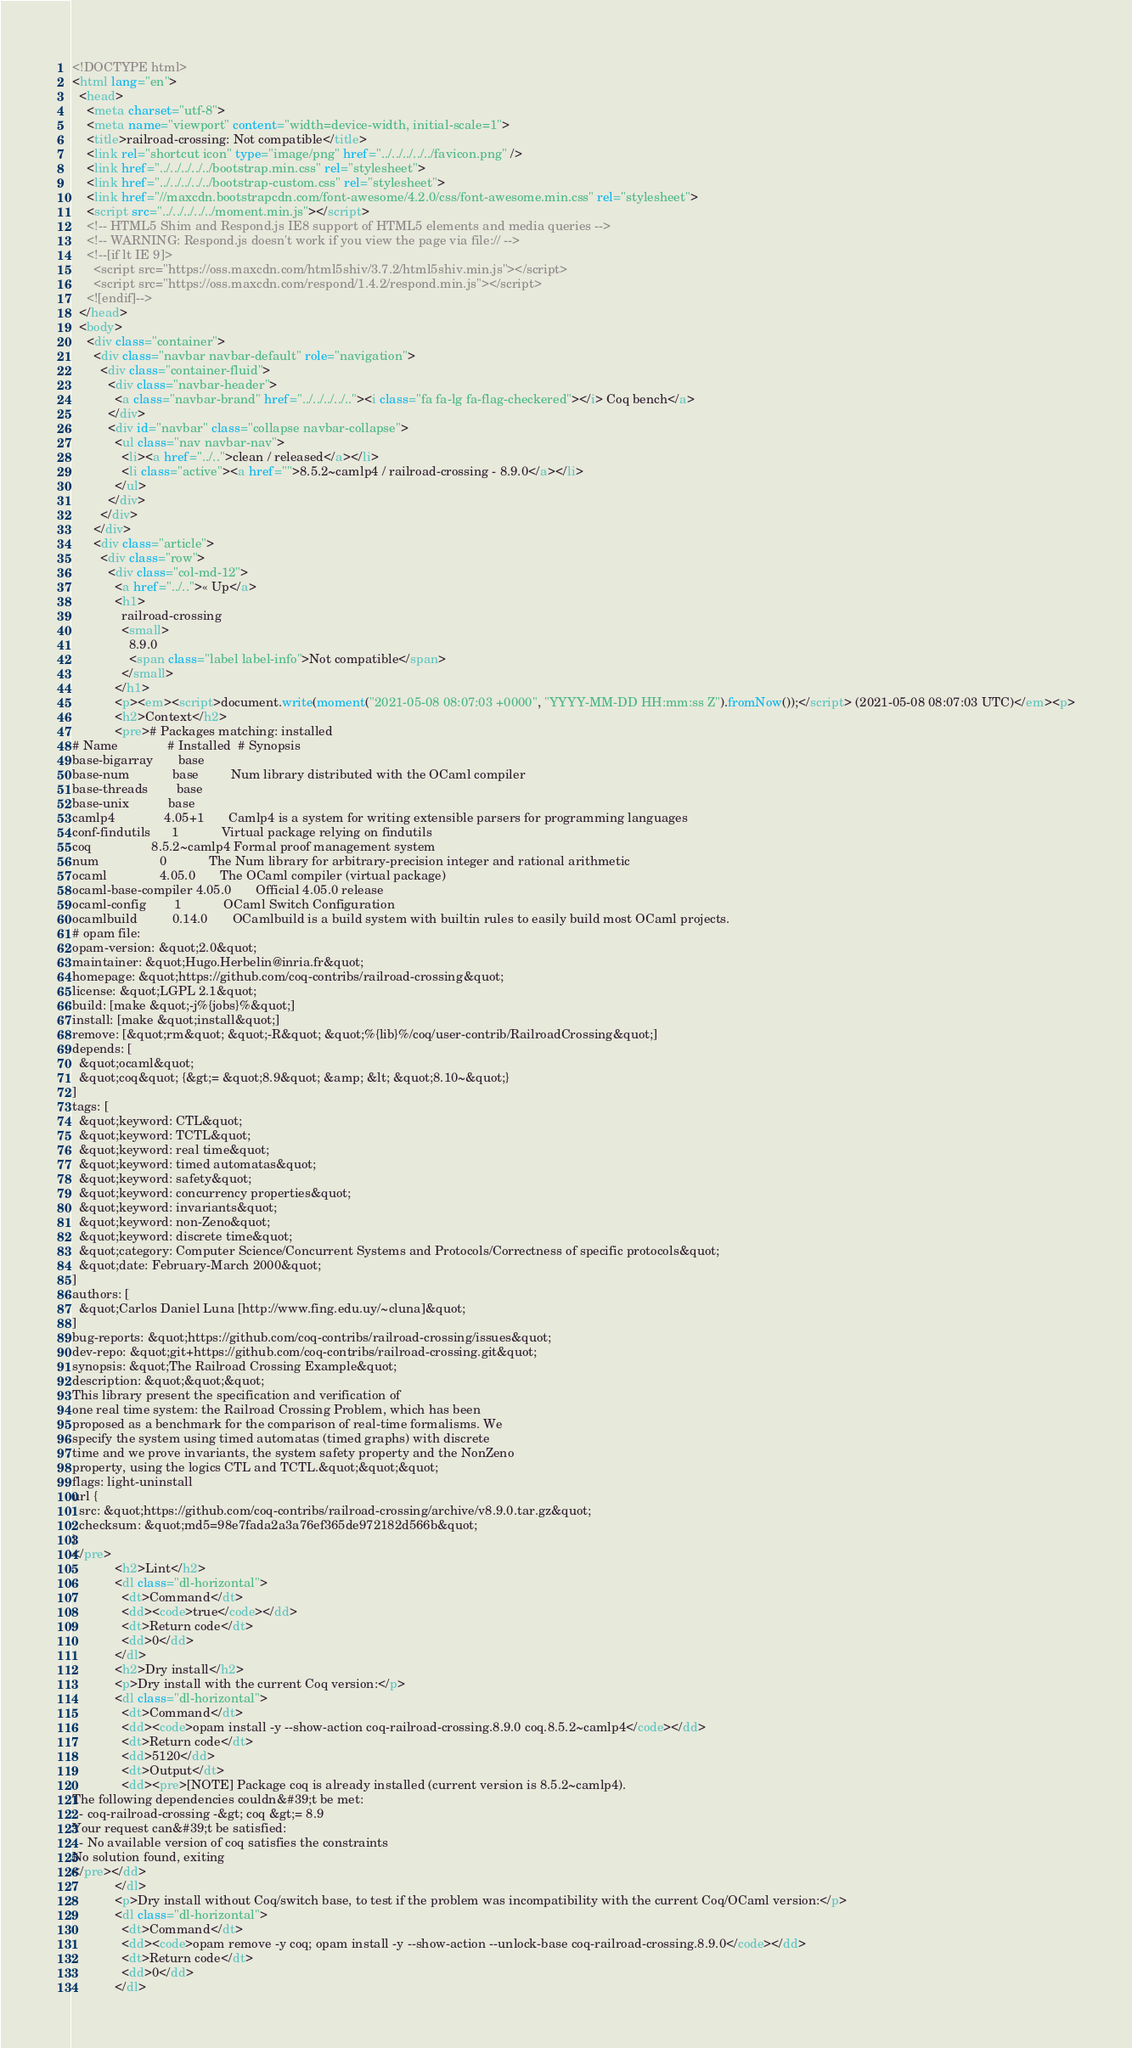<code> <loc_0><loc_0><loc_500><loc_500><_HTML_><!DOCTYPE html>
<html lang="en">
  <head>
    <meta charset="utf-8">
    <meta name="viewport" content="width=device-width, initial-scale=1">
    <title>railroad-crossing: Not compatible</title>
    <link rel="shortcut icon" type="image/png" href="../../../../../favicon.png" />
    <link href="../../../../../bootstrap.min.css" rel="stylesheet">
    <link href="../../../../../bootstrap-custom.css" rel="stylesheet">
    <link href="//maxcdn.bootstrapcdn.com/font-awesome/4.2.0/css/font-awesome.min.css" rel="stylesheet">
    <script src="../../../../../moment.min.js"></script>
    <!-- HTML5 Shim and Respond.js IE8 support of HTML5 elements and media queries -->
    <!-- WARNING: Respond.js doesn't work if you view the page via file:// -->
    <!--[if lt IE 9]>
      <script src="https://oss.maxcdn.com/html5shiv/3.7.2/html5shiv.min.js"></script>
      <script src="https://oss.maxcdn.com/respond/1.4.2/respond.min.js"></script>
    <![endif]-->
  </head>
  <body>
    <div class="container">
      <div class="navbar navbar-default" role="navigation">
        <div class="container-fluid">
          <div class="navbar-header">
            <a class="navbar-brand" href="../../../../.."><i class="fa fa-lg fa-flag-checkered"></i> Coq bench</a>
          </div>
          <div id="navbar" class="collapse navbar-collapse">
            <ul class="nav navbar-nav">
              <li><a href="../..">clean / released</a></li>
              <li class="active"><a href="">8.5.2~camlp4 / railroad-crossing - 8.9.0</a></li>
            </ul>
          </div>
        </div>
      </div>
      <div class="article">
        <div class="row">
          <div class="col-md-12">
            <a href="../..">« Up</a>
            <h1>
              railroad-crossing
              <small>
                8.9.0
                <span class="label label-info">Not compatible</span>
              </small>
            </h1>
            <p><em><script>document.write(moment("2021-05-08 08:07:03 +0000", "YYYY-MM-DD HH:mm:ss Z").fromNow());</script> (2021-05-08 08:07:03 UTC)</em><p>
            <h2>Context</h2>
            <pre># Packages matching: installed
# Name              # Installed  # Synopsis
base-bigarray       base
base-num            base         Num library distributed with the OCaml compiler
base-threads        base
base-unix           base
camlp4              4.05+1       Camlp4 is a system for writing extensible parsers for programming languages
conf-findutils      1            Virtual package relying on findutils
coq                 8.5.2~camlp4 Formal proof management system
num                 0            The Num library for arbitrary-precision integer and rational arithmetic
ocaml               4.05.0       The OCaml compiler (virtual package)
ocaml-base-compiler 4.05.0       Official 4.05.0 release
ocaml-config        1            OCaml Switch Configuration
ocamlbuild          0.14.0       OCamlbuild is a build system with builtin rules to easily build most OCaml projects.
# opam file:
opam-version: &quot;2.0&quot;
maintainer: &quot;Hugo.Herbelin@inria.fr&quot;
homepage: &quot;https://github.com/coq-contribs/railroad-crossing&quot;
license: &quot;LGPL 2.1&quot;
build: [make &quot;-j%{jobs}%&quot;]
install: [make &quot;install&quot;]
remove: [&quot;rm&quot; &quot;-R&quot; &quot;%{lib}%/coq/user-contrib/RailroadCrossing&quot;]
depends: [
  &quot;ocaml&quot;
  &quot;coq&quot; {&gt;= &quot;8.9&quot; &amp; &lt; &quot;8.10~&quot;}
]
tags: [
  &quot;keyword: CTL&quot;
  &quot;keyword: TCTL&quot;
  &quot;keyword: real time&quot;
  &quot;keyword: timed automatas&quot;
  &quot;keyword: safety&quot;
  &quot;keyword: concurrency properties&quot;
  &quot;keyword: invariants&quot;
  &quot;keyword: non-Zeno&quot;
  &quot;keyword: discrete time&quot;
  &quot;category: Computer Science/Concurrent Systems and Protocols/Correctness of specific protocols&quot;
  &quot;date: February-March 2000&quot;
]
authors: [
  &quot;Carlos Daniel Luna [http://www.fing.edu.uy/~cluna]&quot;
]
bug-reports: &quot;https://github.com/coq-contribs/railroad-crossing/issues&quot;
dev-repo: &quot;git+https://github.com/coq-contribs/railroad-crossing.git&quot;
synopsis: &quot;The Railroad Crossing Example&quot;
description: &quot;&quot;&quot;
This library present the specification and verification of
one real time system: the Railroad Crossing Problem, which has been
proposed as a benchmark for the comparison of real-time formalisms. We
specify the system using timed automatas (timed graphs) with discrete
time and we prove invariants, the system safety property and the NonZeno
property, using the logics CTL and TCTL.&quot;&quot;&quot;
flags: light-uninstall
url {
  src: &quot;https://github.com/coq-contribs/railroad-crossing/archive/v8.9.0.tar.gz&quot;
  checksum: &quot;md5=98e7fada2a3a76ef365de972182d566b&quot;
}
</pre>
            <h2>Lint</h2>
            <dl class="dl-horizontal">
              <dt>Command</dt>
              <dd><code>true</code></dd>
              <dt>Return code</dt>
              <dd>0</dd>
            </dl>
            <h2>Dry install</h2>
            <p>Dry install with the current Coq version:</p>
            <dl class="dl-horizontal">
              <dt>Command</dt>
              <dd><code>opam install -y --show-action coq-railroad-crossing.8.9.0 coq.8.5.2~camlp4</code></dd>
              <dt>Return code</dt>
              <dd>5120</dd>
              <dt>Output</dt>
              <dd><pre>[NOTE] Package coq is already installed (current version is 8.5.2~camlp4).
The following dependencies couldn&#39;t be met:
  - coq-railroad-crossing -&gt; coq &gt;= 8.9
Your request can&#39;t be satisfied:
  - No available version of coq satisfies the constraints
No solution found, exiting
</pre></dd>
            </dl>
            <p>Dry install without Coq/switch base, to test if the problem was incompatibility with the current Coq/OCaml version:</p>
            <dl class="dl-horizontal">
              <dt>Command</dt>
              <dd><code>opam remove -y coq; opam install -y --show-action --unlock-base coq-railroad-crossing.8.9.0</code></dd>
              <dt>Return code</dt>
              <dd>0</dd>
            </dl></code> 